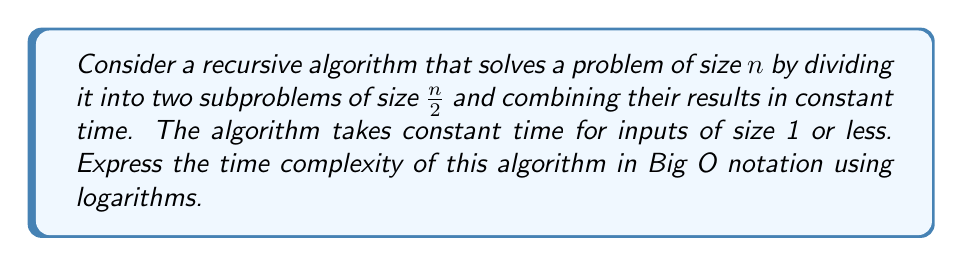Can you solve this math problem? Let's approach this step-by-step:

1) Let $T(n)$ be the time complexity function for our algorithm.

2) We can express $T(n)$ recursively as:
   $$T(n) = \begin{cases}
   c & \text{if } n \leq 1 \\
   2T(\frac{n}{2}) + d & \text{if } n > 1
   \end{cases}$$
   where $c$ and $d$ are constants.

3) This recurrence relation fits the Master Theorem pattern:
   $$T(n) = aT(\frac{n}{b}) + f(n)$$
   where $a = 2$, $b = 2$, and $f(n) = d$ (constant).

4) In the Master Theorem, we compare $n^{\log_b a}$ with $f(n)$:
   $$n^{\log_b a} = n^{\log_2 2} = n^1 = n$$

5) Since $f(n) = d$ (constant) is asymptotically smaller than $n$, we fall into case 1 of the Master Theorem.

6) According to case 1, the solution is:
   $$T(n) = \Theta(n^{\log_b a}) = \Theta(n^{\log_2 2}) = \Theta(n)$$

7) Therefore, the time complexity in Big O notation is $O(n)$.

8) To express this using logarithms, we can write:
   $$O(2^{\log_2 n})$$

This is because $2^{\log_2 n} = n$.
Answer: $O(2^{\log_2 n})$ 